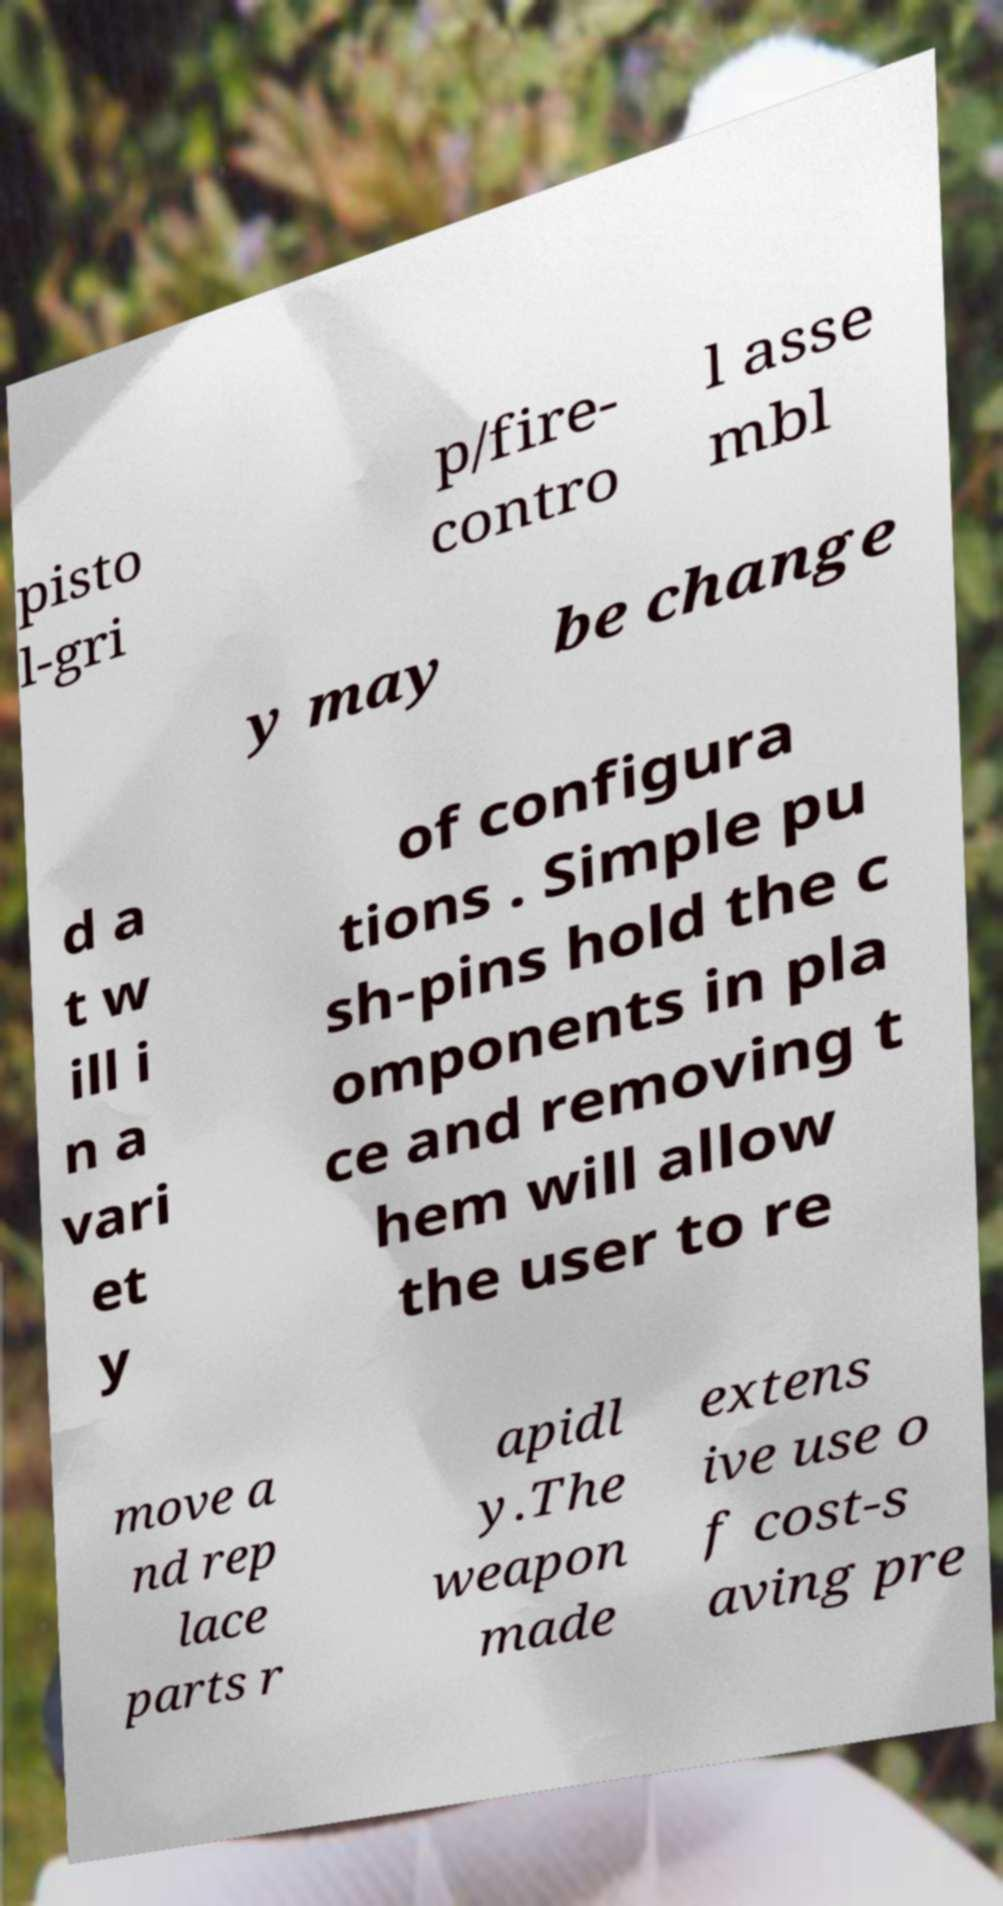I need the written content from this picture converted into text. Can you do that? pisto l-gri p/fire- contro l asse mbl y may be change d a t w ill i n a vari et y of configura tions . Simple pu sh-pins hold the c omponents in pla ce and removing t hem will allow the user to re move a nd rep lace parts r apidl y.The weapon made extens ive use o f cost-s aving pre 